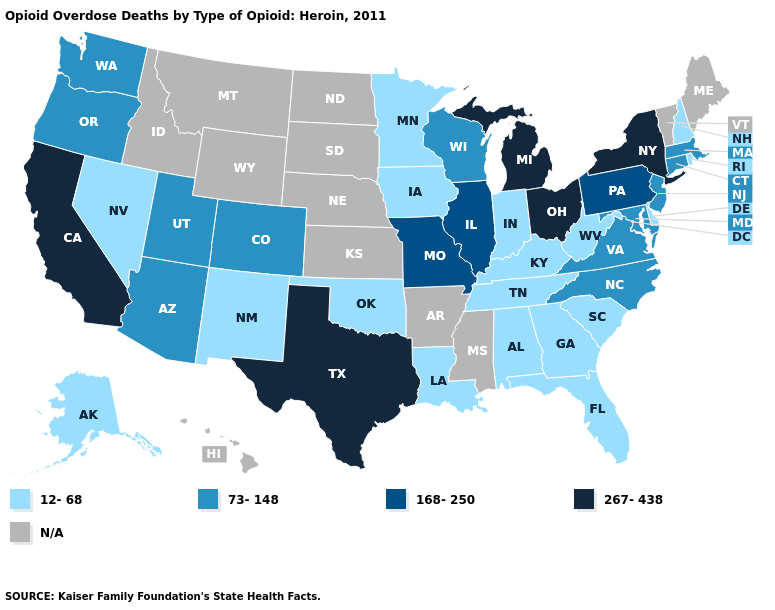Name the states that have a value in the range 168-250?
Keep it brief. Illinois, Missouri, Pennsylvania. Does New Mexico have the lowest value in the West?
Quick response, please. Yes. Does Ohio have the lowest value in the USA?
Answer briefly. No. Which states have the lowest value in the USA?
Keep it brief. Alabama, Alaska, Delaware, Florida, Georgia, Indiana, Iowa, Kentucky, Louisiana, Minnesota, Nevada, New Hampshire, New Mexico, Oklahoma, Rhode Island, South Carolina, Tennessee, West Virginia. What is the value of Kentucky?
Give a very brief answer. 12-68. Name the states that have a value in the range 12-68?
Write a very short answer. Alabama, Alaska, Delaware, Florida, Georgia, Indiana, Iowa, Kentucky, Louisiana, Minnesota, Nevada, New Hampshire, New Mexico, Oklahoma, Rhode Island, South Carolina, Tennessee, West Virginia. What is the lowest value in states that border Indiana?
Concise answer only. 12-68. What is the value of Michigan?
Write a very short answer. 267-438. Which states have the lowest value in the USA?
Be succinct. Alabama, Alaska, Delaware, Florida, Georgia, Indiana, Iowa, Kentucky, Louisiana, Minnesota, Nevada, New Hampshire, New Mexico, Oklahoma, Rhode Island, South Carolina, Tennessee, West Virginia. Name the states that have a value in the range 73-148?
Short answer required. Arizona, Colorado, Connecticut, Maryland, Massachusetts, New Jersey, North Carolina, Oregon, Utah, Virginia, Washington, Wisconsin. Which states have the highest value in the USA?
Quick response, please. California, Michigan, New York, Ohio, Texas. Does Connecticut have the highest value in the USA?
Short answer required. No. What is the value of Arkansas?
Quick response, please. N/A. Name the states that have a value in the range 267-438?
Give a very brief answer. California, Michigan, New York, Ohio, Texas. 